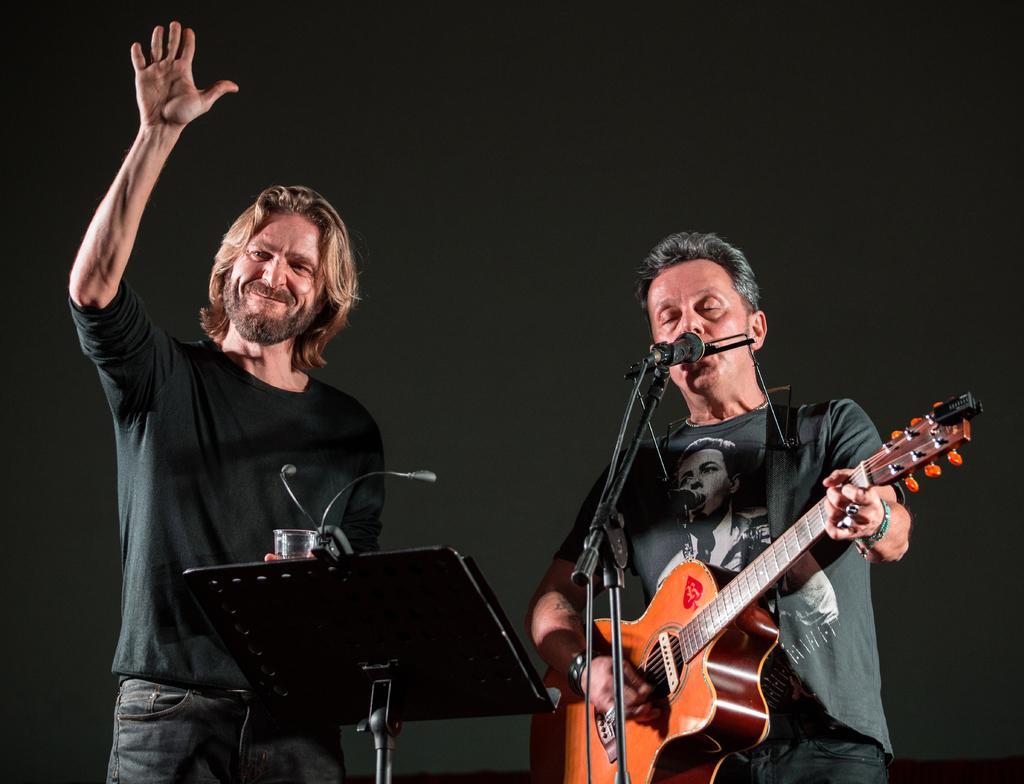Please provide a concise description of this image. In this picture there is a man wearing a black t shirt is standing. There is also other man wearing a grey shirt is playing a guitar and singing. There is a mic. 